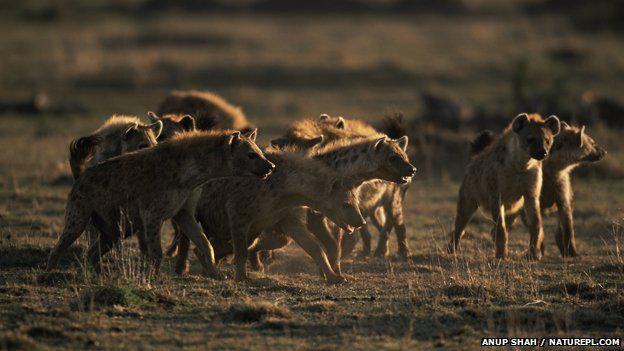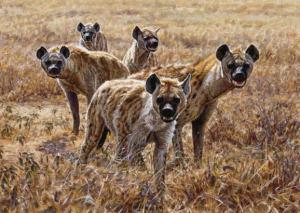The first image is the image on the left, the second image is the image on the right. For the images displayed, is the sentence "At least one image has a  single tan and black hyena opening its mouth showing its teeth." factually correct? Answer yes or no. No. The first image is the image on the left, the second image is the image on the right. Given the left and right images, does the statement "In one of the image the pack of hyenas are moving right." hold true? Answer yes or no. Yes. 